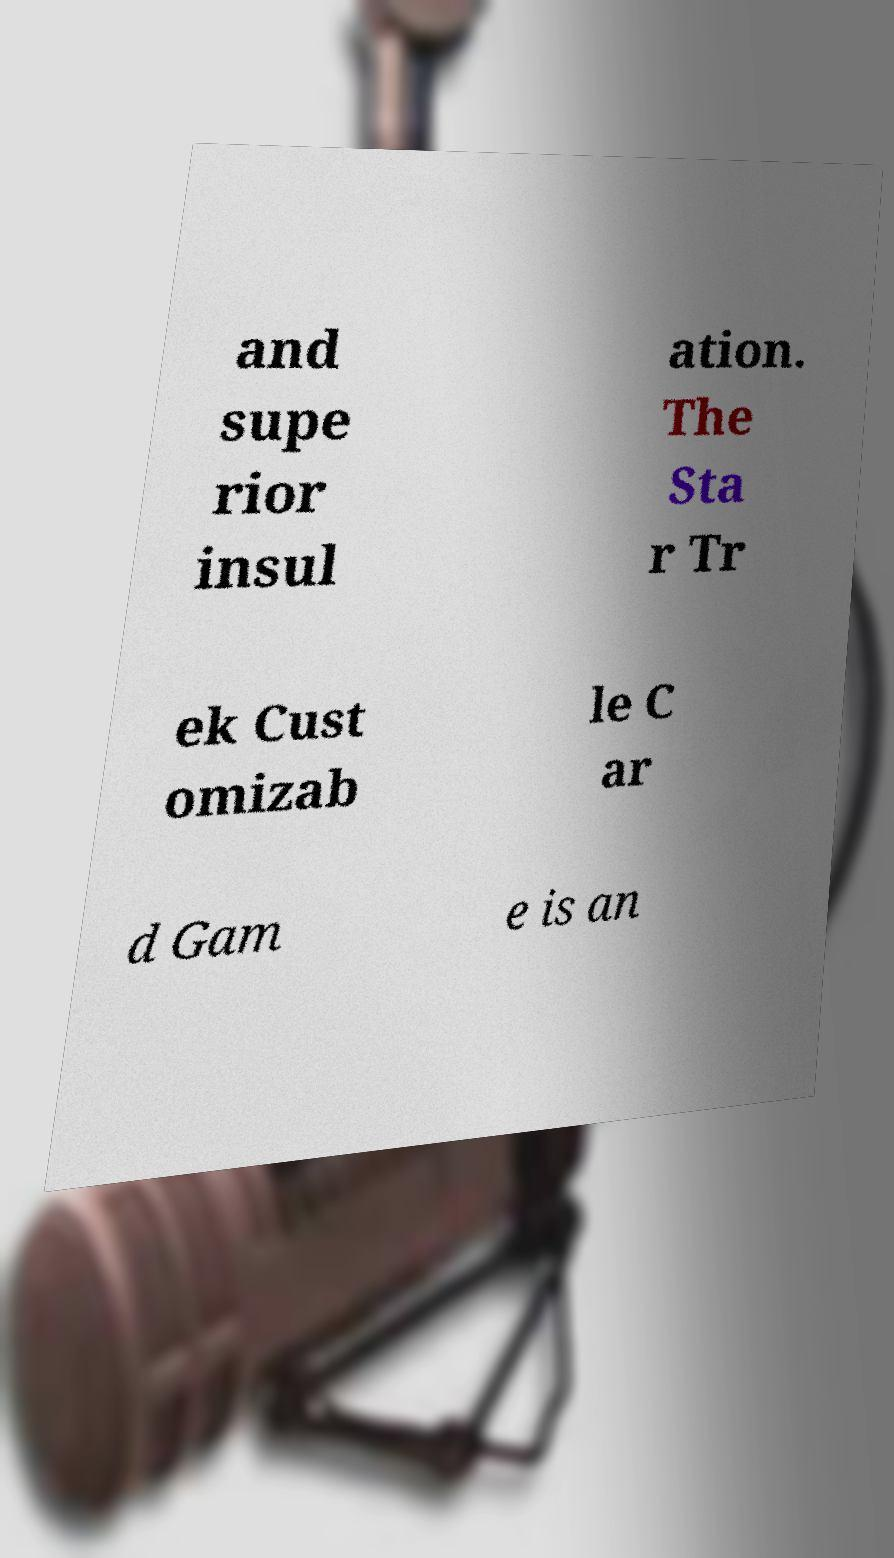Please read and relay the text visible in this image. What does it say? and supe rior insul ation. The Sta r Tr ek Cust omizab le C ar d Gam e is an 